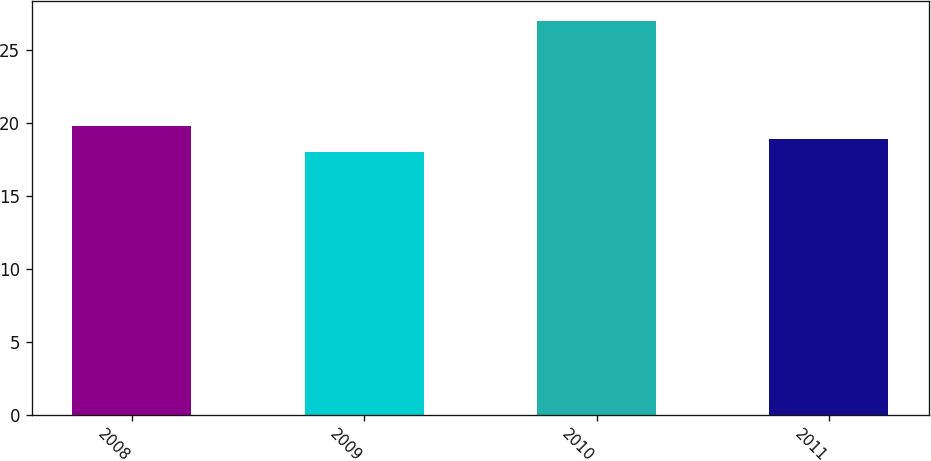Convert chart. <chart><loc_0><loc_0><loc_500><loc_500><bar_chart><fcel>2008<fcel>2009<fcel>2010<fcel>2011<nl><fcel>19.8<fcel>18<fcel>27<fcel>18.9<nl></chart> 